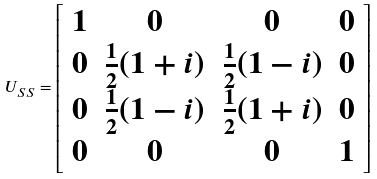Convert formula to latex. <formula><loc_0><loc_0><loc_500><loc_500>U _ { S S } = \left [ \begin{array} { c c c c } 1 & 0 & 0 & 0 \\ 0 & \frac { 1 } { 2 } ( 1 + i ) & \frac { 1 } { 2 } ( 1 - i ) & 0 \\ 0 & \frac { 1 } { 2 } ( 1 - i ) & \frac { 1 } { 2 } ( 1 + i ) & 0 \\ 0 & 0 & 0 & 1 \end{array} \right ]</formula> 